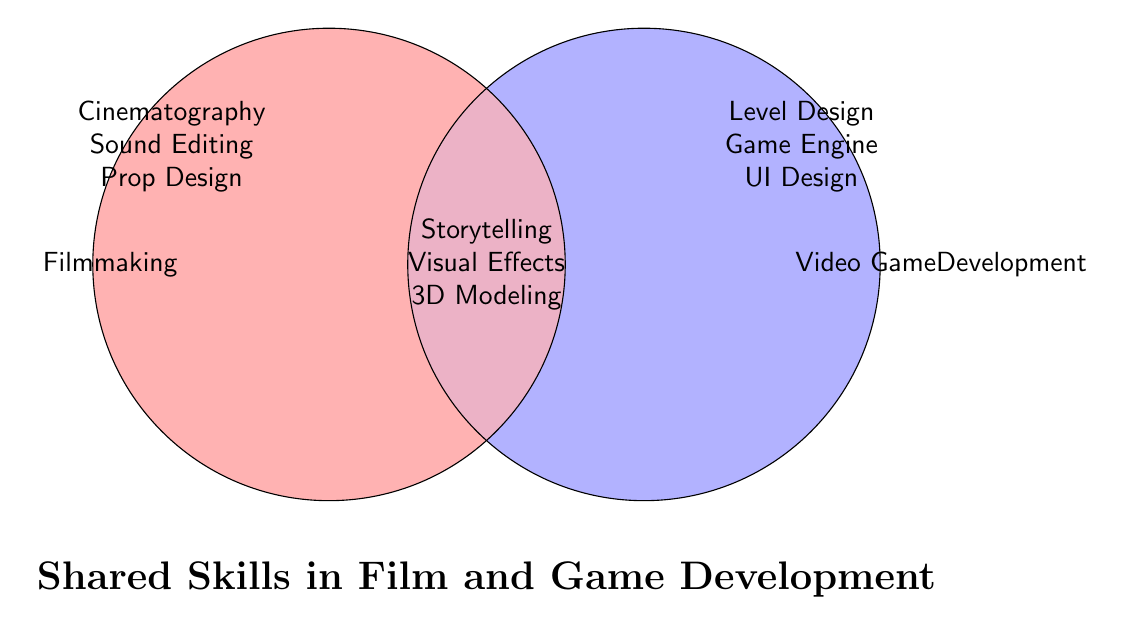What are the skills listed only under Filmmaking? We can look at the segment labeled "Filmmaking" which is not overlapped with "Video Game Development" to find these skills.
Answer: Cinematography, Sound Editing, Prop Design, Costume Design, Film Editing, Practical Effects What is the common skill associated with both Filmmaking and Video Game Development related to visual creativity? Visual creativity can be associated with the term "Visual Effects." We notice it is in the intersecting area, indicating it is a common skill.
Answer: Visual Effects How many unique skills are noted for Video Game Development? We count the skills exclusively under "Video Game Development" and those in the overlapping area, but we cannot double-count shared skills. Exclusive skills are Level Design, Game Engine Programming, UI Design, Playtesting, Multiplayer Networking, AI, and Physics Simulation.
Answer: 7 Which area indicates shared skills between Filmmaking and Video Game Development? The overlapping area of the circles, marked in a different color (purple), lists shared skills.
Answer: The overlapping area Which field has skills related to design (excluding the shared skills)? Looking individually at the non-overlapping parts, for Filmmaking, we have Costume Design and Prop Design. For Video Game Development, we have Level Design and UI Design. Comparing, both filmmaking and video game development have design-related skills.
Answer: Both What is the combined count of unique skills in Filmmaking and Video Game Development (excluding shared)? Count the individual unique skills in both non-overlapping areas. Filmmaking has 6 unique skills, and Video Game Development has 7. Add these together.
Answer: 13 How many skills are identified as common skills? Look at the intersecting area of the Venn Diagram, which represents the common skills. Count the number of skills shown there.
Answer: 3 